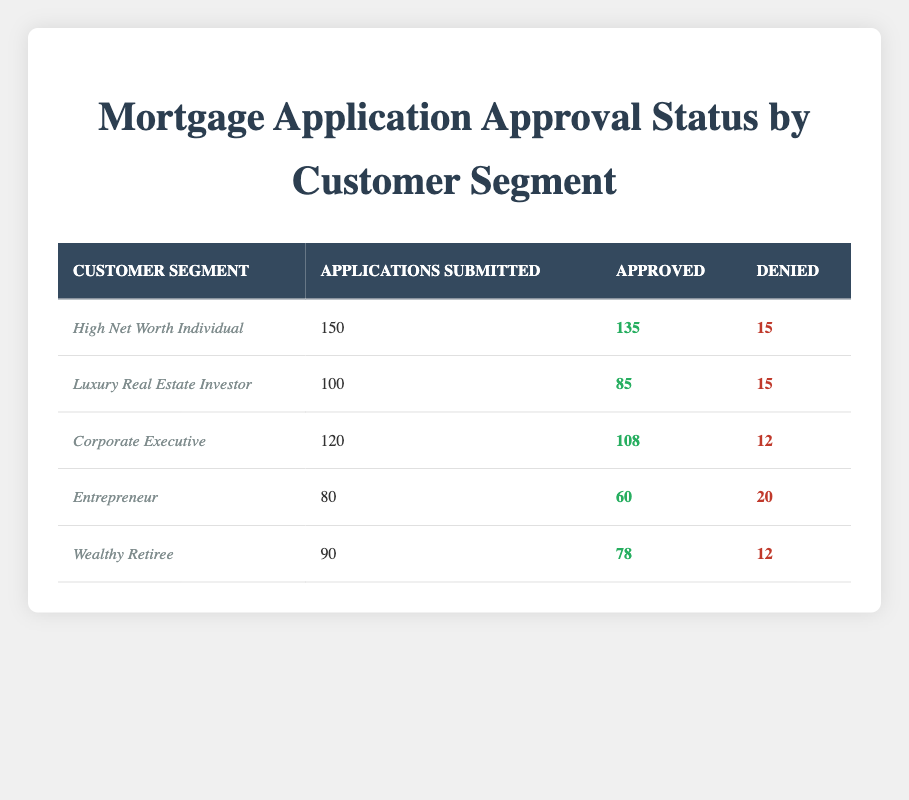What is the total number of mortgage applications submitted by the High Net Worth Individuals? The table shows that the High Net Worth Individual segment has submitted a total of 150 applications.
Answer: 150 How many applications were approved for Luxury Real Estate Investors? According to the table, 85 applications were approved in the Luxury Real Estate Investor segment.
Answer: 85 What is the approval rate for Corporate Executives? To find the approval rate for Corporate Executives, divide the number of approved applications (108) by the total applications submitted (120). Thus, the approval rate is (108/120) * 100 ≈ 90%.
Answer: 90% Is the number of denied applications for Entrepreneurs greater than that for Wealthy Retirees? The table shows that Entrepreneurs had 20 denied applications while Wealthy Retirees had 12. Since 20 is greater than 12, the statement is true.
Answer: Yes What is the average number of applications submitted across all customer segments? To find the average, sum all the applications submitted: 150 + 100 + 120 + 80 + 90 = 540. Then divide by 5 (the number of segments): 540 / 5 = 108.
Answer: 108 How many total applications were denied across all segments? The total number of denied applications is found by adding up the denied counts: 15 + 15 + 12 + 20 + 12 = 74.
Answer: 74 What is the difference in approved applications between High Net Worth Individuals and Wealthy Retirees? High Net Worth Individuals have 135 approved applications while Wealthy Retirees have 78. The difference is 135 - 78 = 57.
Answer: 57 Which customer segment has the highest number of denied applications? By comparing the denied applications, we see that Entrepreneurs with 20 denied applications have the highest number compared to others which have less.
Answer: Entrepreneurs What percentage of applications for Luxury Real Estate Investors were approved? To find the approval percentage, divide the number of approved (85) by the total submitted (100) and multiply by 100: (85/100) * 100 = 85%.
Answer: 85% 